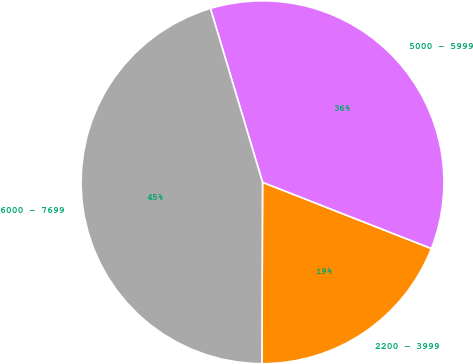Convert chart. <chart><loc_0><loc_0><loc_500><loc_500><pie_chart><fcel>2200 - 3999<fcel>5000 - 5999<fcel>6000 - 7699<nl><fcel>19.1%<fcel>35.59%<fcel>45.31%<nl></chart> 